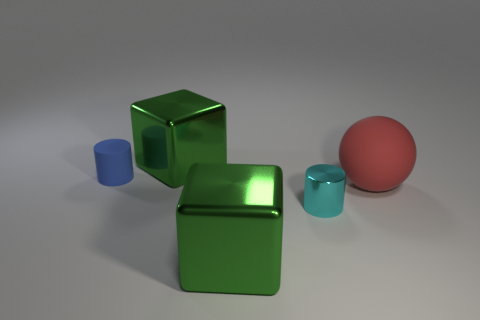Is there a small matte thing of the same color as the large rubber object?
Keep it short and to the point. No. Do the metallic cube that is in front of the metallic cylinder and the small cyan metal object have the same size?
Give a very brief answer. No. What color is the matte cylinder?
Your answer should be compact. Blue. The large metallic object to the right of the big green object behind the cyan object is what color?
Offer a terse response. Green. Are there any tiny objects that have the same material as the red ball?
Keep it short and to the point. Yes. There is a large green object right of the shiny cube that is behind the cyan metallic thing; what is it made of?
Your response must be concise. Metal. What number of other tiny rubber objects have the same shape as the cyan object?
Your answer should be very brief. 1. What shape is the large red object?
Make the answer very short. Sphere. Are there fewer green shiny blocks than large objects?
Offer a very short reply. Yes. What material is the other small object that is the same shape as the tiny blue rubber thing?
Your answer should be compact. Metal. 